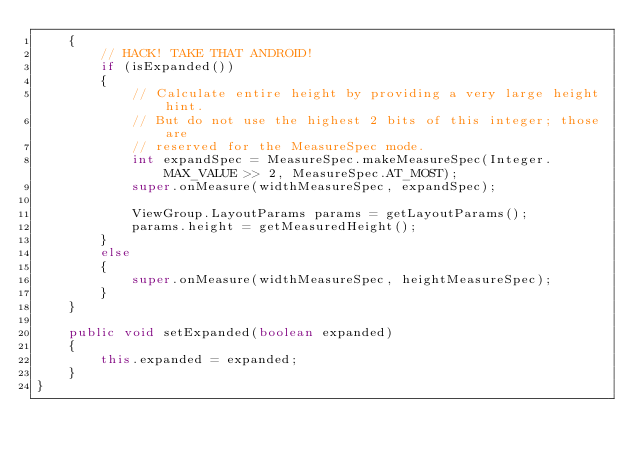Convert code to text. <code><loc_0><loc_0><loc_500><loc_500><_Java_>    {
        // HACK! TAKE THAT ANDROID!
        if (isExpanded())
        {
            // Calculate entire height by providing a very large height hint.
            // But do not use the highest 2 bits of this integer; those are
            // reserved for the MeasureSpec mode.
            int expandSpec = MeasureSpec.makeMeasureSpec(Integer.MAX_VALUE >> 2, MeasureSpec.AT_MOST);
            super.onMeasure(widthMeasureSpec, expandSpec);

            ViewGroup.LayoutParams params = getLayoutParams();
            params.height = getMeasuredHeight();
        }
        else
        {
            super.onMeasure(widthMeasureSpec, heightMeasureSpec);
        }
    }

    public void setExpanded(boolean expanded)
    {
        this.expanded = expanded;
    }
}</code> 